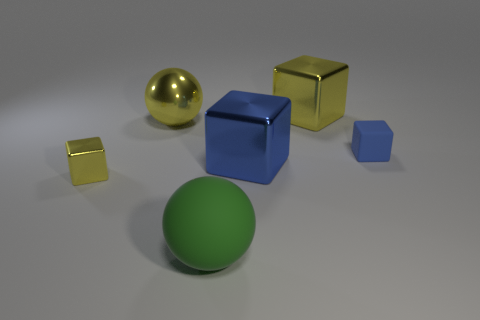Do the blue rubber object and the yellow metal ball have the same size?
Ensure brevity in your answer.  No. How many objects are large balls behind the tiny metallic cube or blocks that are right of the big green rubber sphere?
Your answer should be compact. 4. Is the number of large green balls that are to the right of the big matte object greater than the number of big cyan balls?
Your answer should be very brief. No. How many other things are there of the same shape as the large green thing?
Give a very brief answer. 1. What is the material of the cube that is in front of the blue rubber cube and on the right side of the small yellow thing?
Offer a terse response. Metal. What number of things are green rubber spheres or small yellow shiny cubes?
Offer a very short reply. 2. Is the number of small blue rubber objects greater than the number of large metal cylinders?
Offer a very short reply. Yes. How big is the metallic block that is behind the matte object that is behind the small yellow thing?
Give a very brief answer. Large. There is another big shiny thing that is the same shape as the green thing; what is its color?
Ensure brevity in your answer.  Yellow. What is the size of the matte cube?
Your answer should be compact. Small. 